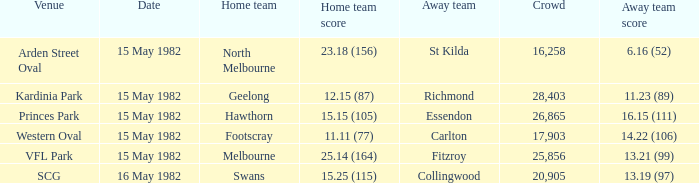Which home team played against the away team with a score of 13.19 (97)? Swans. 